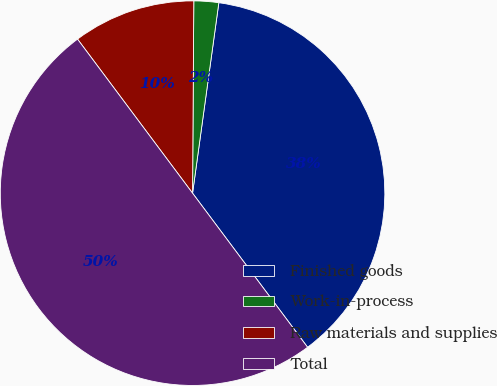<chart> <loc_0><loc_0><loc_500><loc_500><pie_chart><fcel>Finished goods<fcel>Work-in-process<fcel>Raw materials and supplies<fcel>Total<nl><fcel>37.61%<fcel>2.08%<fcel>10.31%<fcel>50.0%<nl></chart> 